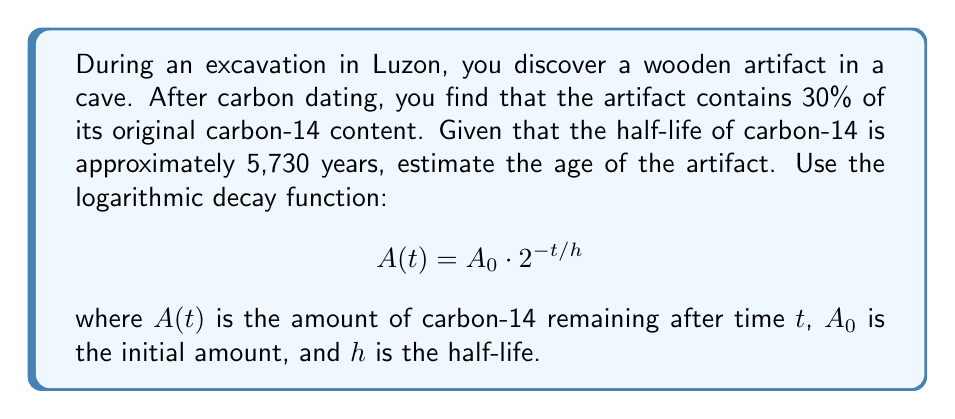Solve this math problem. To solve this problem, we'll use the logarithmic decay function and follow these steps:

1) We know that 30% of the original carbon-14 remains, so $A(t)/A_0 = 0.30$

2) Substituting into the decay function:

   $$0.30 = 2^{-t/5730}$$

3) Take the natural logarithm of both sides:

   $$\ln(0.30) = \ln(2^{-t/5730})$$

4) Using the logarithm property $\ln(x^n) = n\ln(x)$:

   $$\ln(0.30) = -\frac{t}{5730}\ln(2)$$

5) Solve for $t$:

   $$t = -5730 \cdot \frac{\ln(0.30)}{\ln(2)}$$

6) Calculate the result:

   $$t \approx 9934.3$$

Therefore, the estimated age of the artifact is approximately 9,934 years.
Answer: The estimated age of the artifact is approximately 9,934 years. 